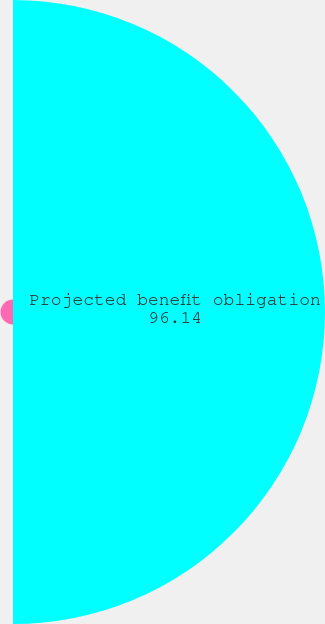Convert chart to OTSL. <chart><loc_0><loc_0><loc_500><loc_500><pie_chart><fcel>Projected benefit obligation<fcel>Net periodic pension cost<nl><fcel>96.14%<fcel>3.86%<nl></chart> 